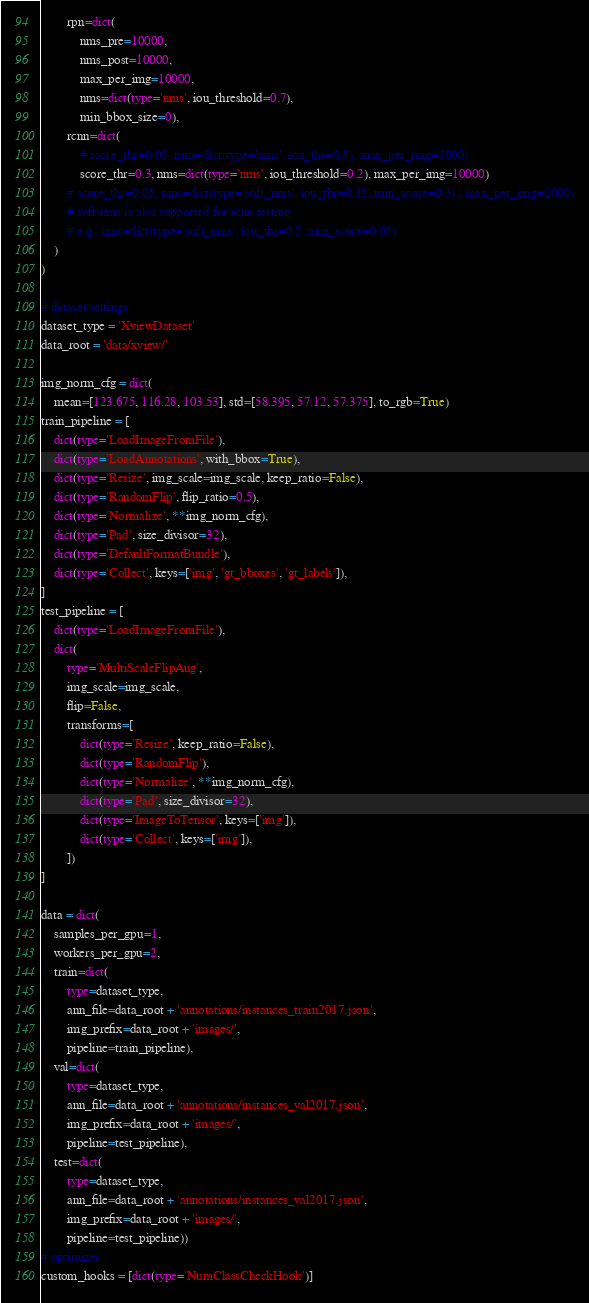<code> <loc_0><loc_0><loc_500><loc_500><_Python_>        rpn=dict(
            nms_pre=10000,
            nms_post=10000,
            max_per_img=10000,
            nms=dict(type='nms', iou_threshold=0.7),
            min_bbox_size=0),
        rcnn=dict(
            # score_thr=0.05, nms=dict(type='nms', iou_thr=0.5), max_per_img=2000)
            score_thr=0.3, nms=dict(type='nms', iou_threshold=0.2), max_per_img=10000)
        # score_thr=0.05, nms=dict(type='soft_nms', iou_thr=0.15, min_score=0.3) , max_per_img=2000)
        # soft-nms is also supported for rcnn testing
        # e.g., nms=dict(type='soft_nms', iou_thr=0.5, min_score=0.05)
    )
)

# dataset settings
dataset_type = 'XviewDataset'
data_root = 'data/xview/'

img_norm_cfg = dict(
    mean=[123.675, 116.28, 103.53], std=[58.395, 57.12, 57.375], to_rgb=True)
train_pipeline = [
    dict(type='LoadImageFromFile'),
    dict(type='LoadAnnotations', with_bbox=True),
    dict(type='Resize', img_scale=img_scale, keep_ratio=False),
    dict(type='RandomFlip', flip_ratio=0.5),
    dict(type='Normalize', **img_norm_cfg),
    dict(type='Pad', size_divisor=32),
    dict(type='DefaultFormatBundle'),
    dict(type='Collect', keys=['img', 'gt_bboxes', 'gt_labels']),
]
test_pipeline = [
    dict(type='LoadImageFromFile'),
    dict(
        type='MultiScaleFlipAug',
        img_scale=img_scale,
        flip=False,
        transforms=[
            dict(type='Resize', keep_ratio=False),
            dict(type='RandomFlip'),
            dict(type='Normalize', **img_norm_cfg),
            dict(type='Pad', size_divisor=32),
            dict(type='ImageToTensor', keys=['img']),
            dict(type='Collect', keys=['img']),
        ])
]

data = dict(
    samples_per_gpu=1,
    workers_per_gpu=2,
    train=dict(
        type=dataset_type,
        ann_file=data_root + 'annotations/instances_train2017.json',
        img_prefix=data_root + 'images/',
        pipeline=train_pipeline),
    val=dict(
        type=dataset_type,
        ann_file=data_root + 'annotations/instances_val2017.json',
        img_prefix=data_root + 'images/',
        pipeline=test_pipeline),
    test=dict(
        type=dataset_type,
        ann_file=data_root + 'annotations/instances_val2017.json',
        img_prefix=data_root + 'images/',
        pipeline=test_pipeline))
# optimizer
custom_hooks = [dict(type='NumClassCheckHook')]</code> 